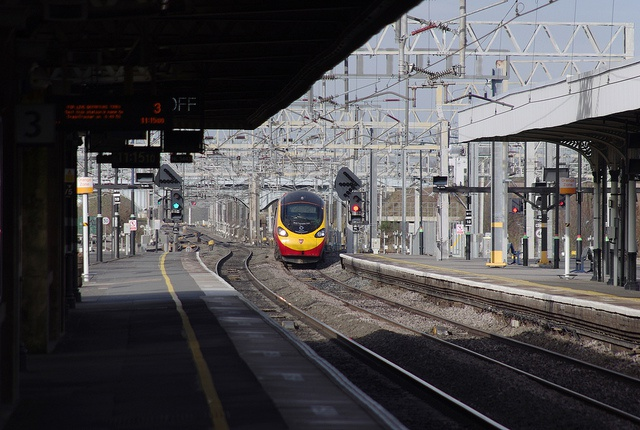Describe the objects in this image and their specific colors. I can see train in black, gray, and brown tones, traffic light in black, gray, and purple tones, traffic light in black, gray, and purple tones, traffic light in black, gray, and gold tones, and traffic light in black, maroon, gray, and brown tones in this image. 